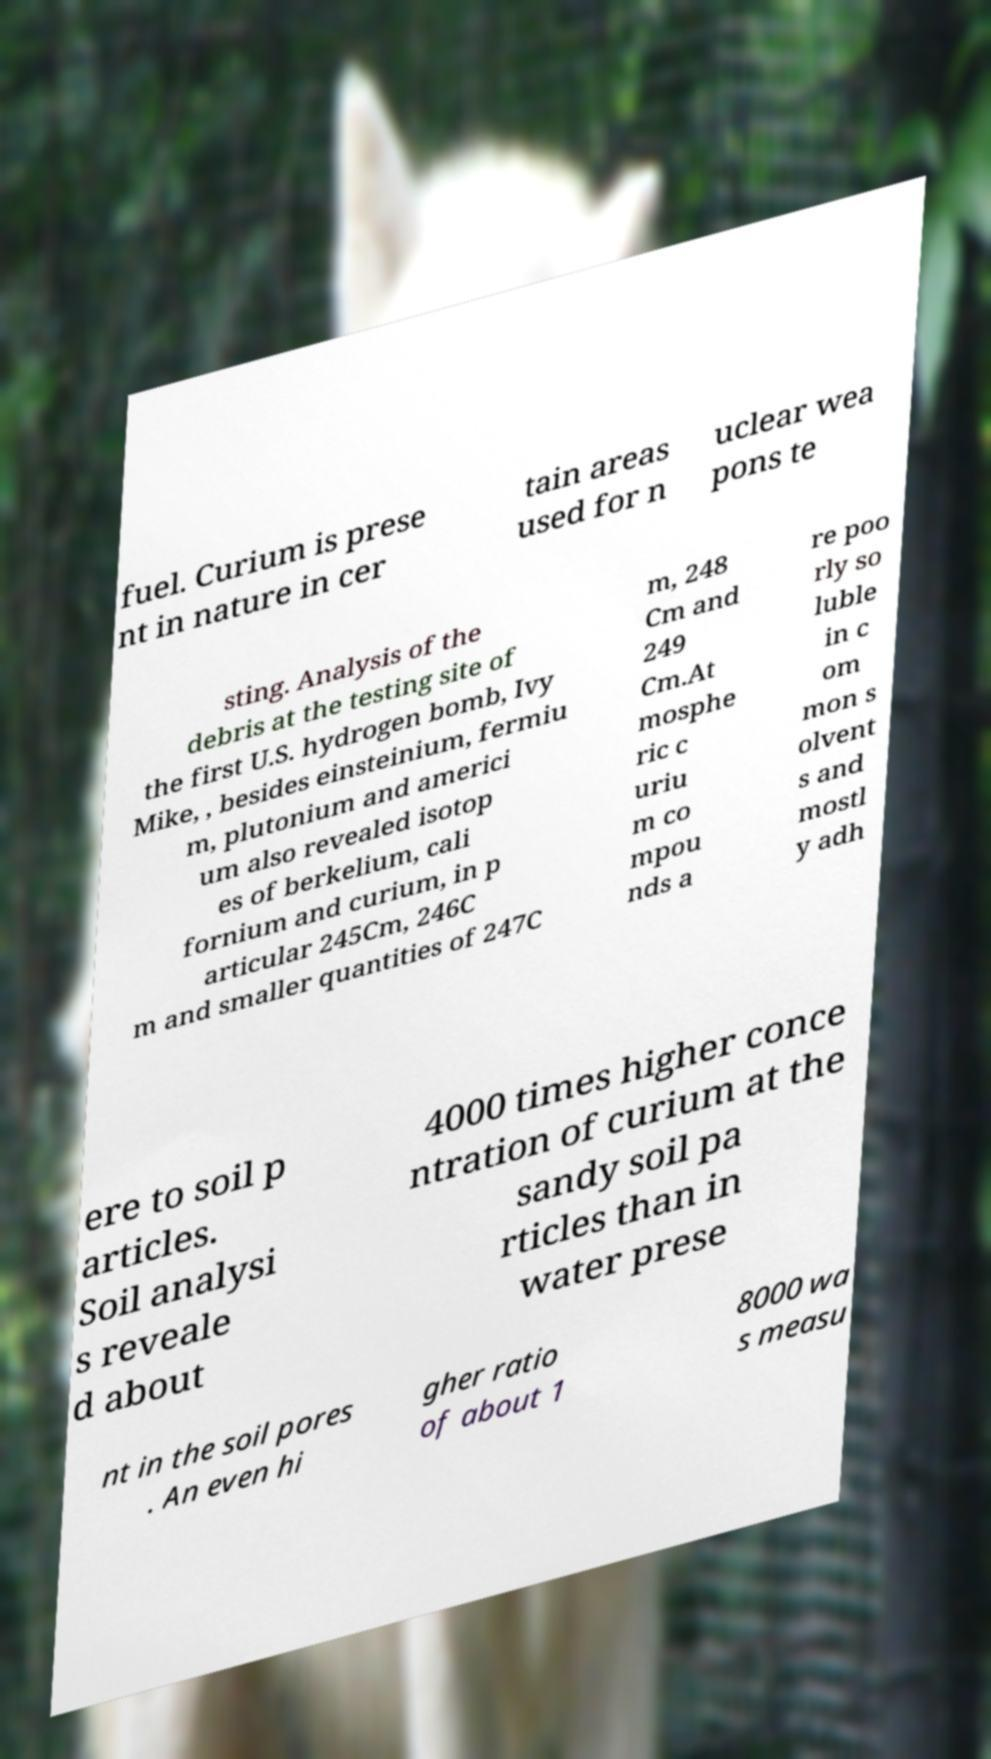For documentation purposes, I need the text within this image transcribed. Could you provide that? fuel. Curium is prese nt in nature in cer tain areas used for n uclear wea pons te sting. Analysis of the debris at the testing site of the first U.S. hydrogen bomb, Ivy Mike, , besides einsteinium, fermiu m, plutonium and americi um also revealed isotop es of berkelium, cali fornium and curium, in p articular 245Cm, 246C m and smaller quantities of 247C m, 248 Cm and 249 Cm.At mosphe ric c uriu m co mpou nds a re poo rly so luble in c om mon s olvent s and mostl y adh ere to soil p articles. Soil analysi s reveale d about 4000 times higher conce ntration of curium at the sandy soil pa rticles than in water prese nt in the soil pores . An even hi gher ratio of about 1 8000 wa s measu 